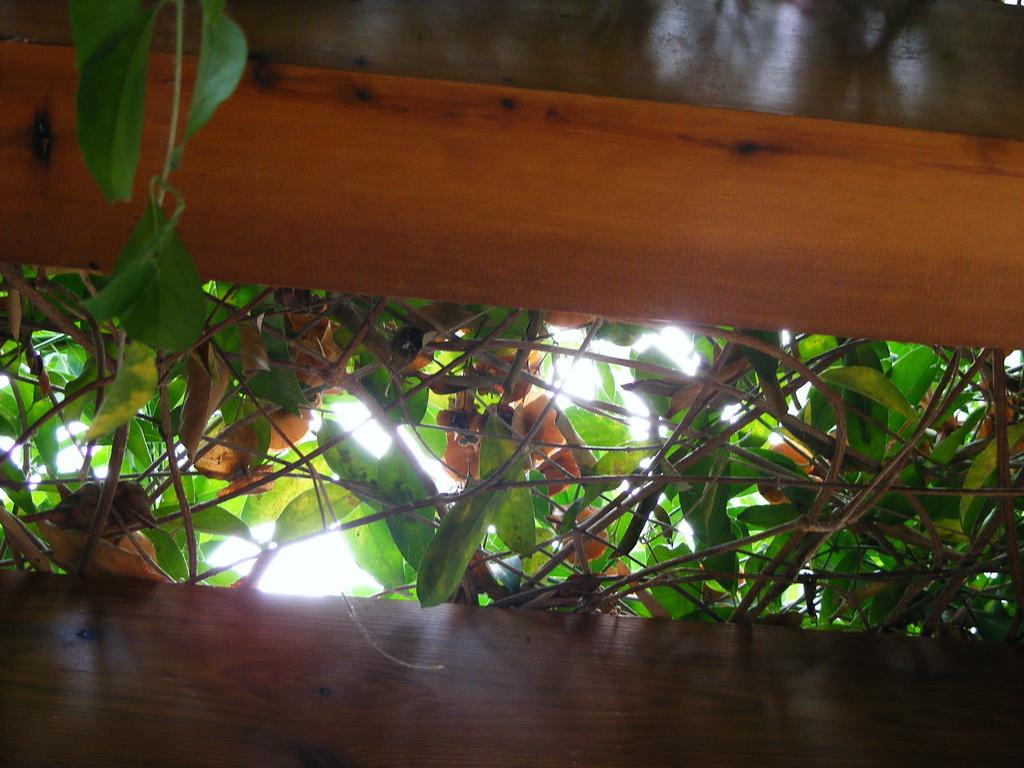What type of living organisms can be seen in the image? Plants can be seen in the image. What material are the poles made of in the image? The poles in the image are made of wood. Can you tell me which part of the woman's body is visible in the image? There is no woman present in the image; it features plants and wooden poles. What type of gate is visible in the image? There is no gate present in the image; it features plants and wooden poles. 